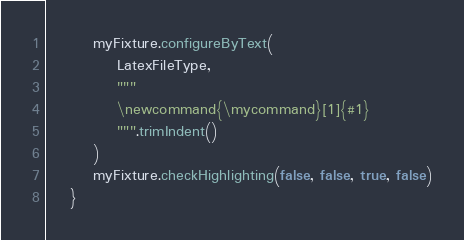Convert code to text. <code><loc_0><loc_0><loc_500><loc_500><_Kotlin_>        myFixture.configureByText(
            LatexFileType,
            """
            \newcommand{\mycommand}[1]{#1}
            """.trimIndent()
        )
        myFixture.checkHighlighting(false, false, true, false)
    }
</code> 